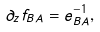Convert formula to latex. <formula><loc_0><loc_0><loc_500><loc_500>\partial _ { z } f _ { B A } = e _ { B A } ^ { - 1 } ,</formula> 